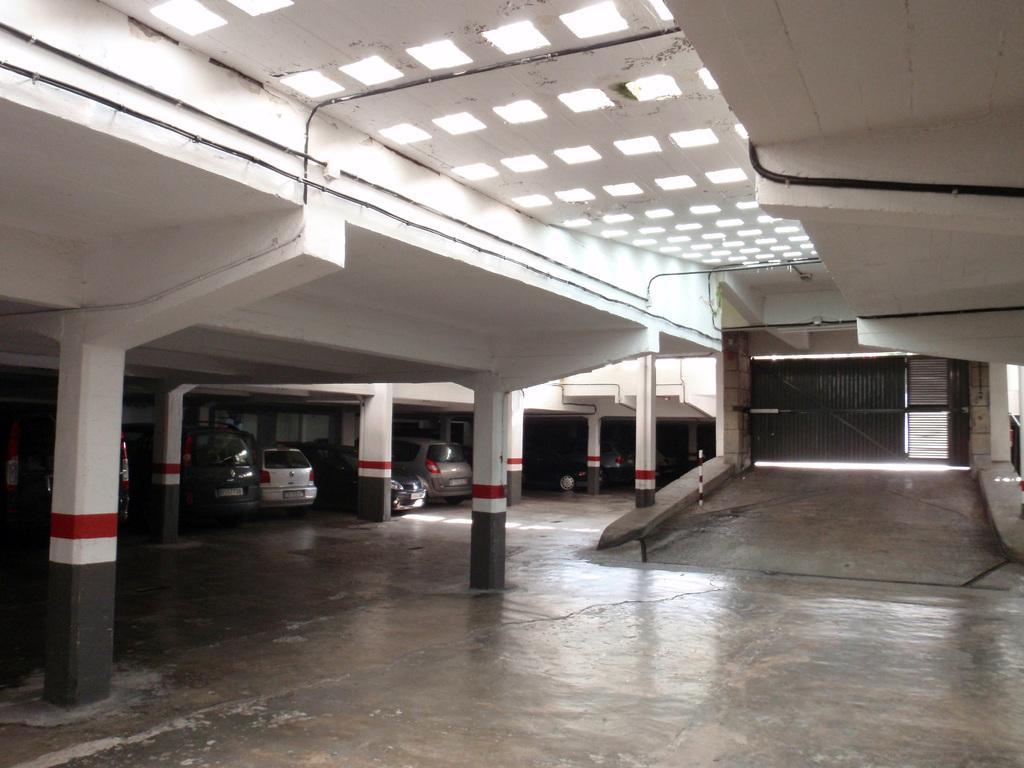Can you describe this image briefly? In this picture we can see a gate, pillars, lights, some objects and in the background we can see vehicles on the floor. 